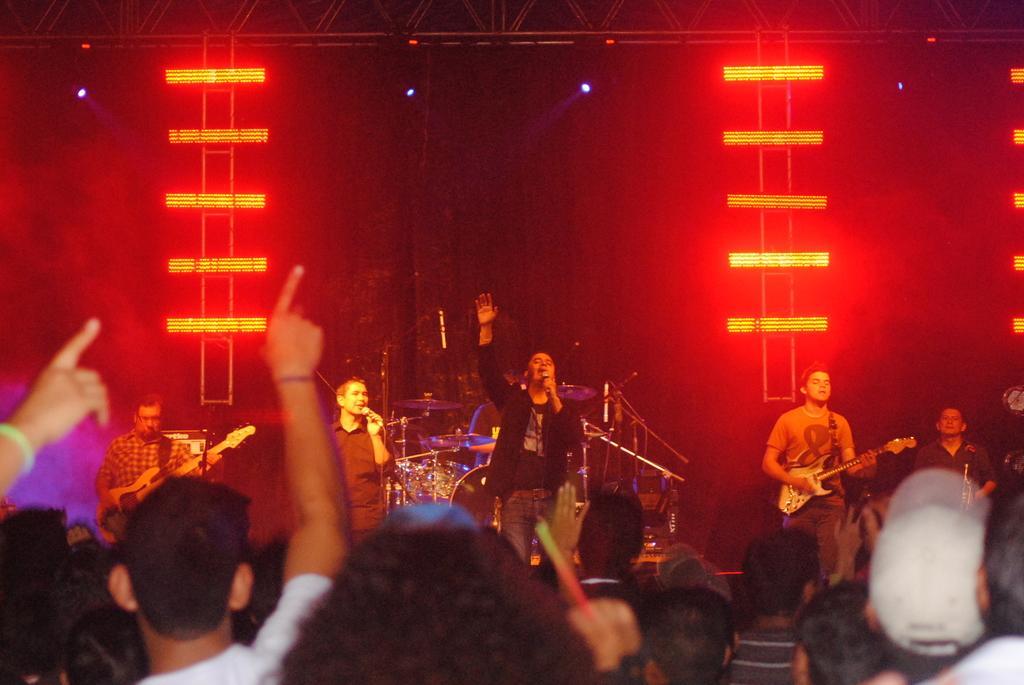In one or two sentences, can you explain what this image depicts? In this image I can see people among them some are on the stage. Among them some are holding musical instruments and microphones. In the background I can see lights and other objects. 